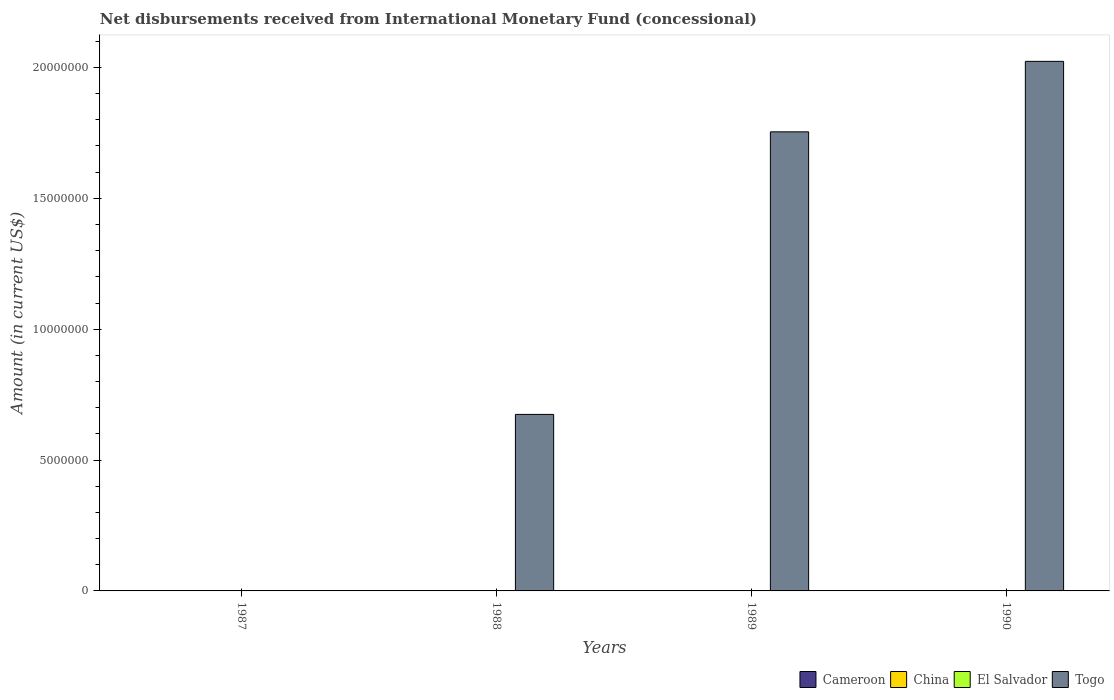How many different coloured bars are there?
Offer a very short reply. 1. Are the number of bars per tick equal to the number of legend labels?
Make the answer very short. No. Are the number of bars on each tick of the X-axis equal?
Provide a succinct answer. No. How many bars are there on the 1st tick from the left?
Your answer should be very brief. 0. How many bars are there on the 3rd tick from the right?
Provide a succinct answer. 1. What is the label of the 2nd group of bars from the left?
Make the answer very short. 1988. What is the amount of disbursements received from International Monetary Fund in China in 1990?
Give a very brief answer. 0. What is the total amount of disbursements received from International Monetary Fund in Togo in the graph?
Your answer should be very brief. 4.45e+07. What is the difference between the amount of disbursements received from International Monetary Fund in Togo in 1988 and that in 1990?
Provide a succinct answer. -1.35e+07. What is the difference between the amount of disbursements received from International Monetary Fund in China in 1989 and the amount of disbursements received from International Monetary Fund in El Salvador in 1990?
Make the answer very short. 0. In how many years, is the amount of disbursements received from International Monetary Fund in El Salvador greater than 10000000 US$?
Give a very brief answer. 0. What is the difference between the highest and the second highest amount of disbursements received from International Monetary Fund in Togo?
Your answer should be compact. 2.69e+06. What is the difference between the highest and the lowest amount of disbursements received from International Monetary Fund in Togo?
Keep it short and to the point. 2.02e+07. In how many years, is the amount of disbursements received from International Monetary Fund in Togo greater than the average amount of disbursements received from International Monetary Fund in Togo taken over all years?
Keep it short and to the point. 2. Is it the case that in every year, the sum of the amount of disbursements received from International Monetary Fund in Togo and amount of disbursements received from International Monetary Fund in El Salvador is greater than the sum of amount of disbursements received from International Monetary Fund in China and amount of disbursements received from International Monetary Fund in Cameroon?
Your answer should be very brief. No. Is it the case that in every year, the sum of the amount of disbursements received from International Monetary Fund in China and amount of disbursements received from International Monetary Fund in Cameroon is greater than the amount of disbursements received from International Monetary Fund in El Salvador?
Offer a very short reply. No. How many bars are there?
Provide a short and direct response. 3. Are all the bars in the graph horizontal?
Give a very brief answer. No. Does the graph contain grids?
Your answer should be very brief. No. How many legend labels are there?
Your answer should be very brief. 4. How are the legend labels stacked?
Your response must be concise. Horizontal. What is the title of the graph?
Provide a succinct answer. Net disbursements received from International Monetary Fund (concessional). Does "Grenada" appear as one of the legend labels in the graph?
Provide a short and direct response. No. What is the label or title of the X-axis?
Provide a succinct answer. Years. What is the Amount (in current US$) in Cameroon in 1987?
Keep it short and to the point. 0. What is the Amount (in current US$) in El Salvador in 1987?
Provide a short and direct response. 0. What is the Amount (in current US$) in China in 1988?
Offer a terse response. 0. What is the Amount (in current US$) of El Salvador in 1988?
Make the answer very short. 0. What is the Amount (in current US$) in Togo in 1988?
Offer a very short reply. 6.74e+06. What is the Amount (in current US$) of China in 1989?
Offer a terse response. 0. What is the Amount (in current US$) of El Salvador in 1989?
Your response must be concise. 0. What is the Amount (in current US$) in Togo in 1989?
Your answer should be compact. 1.75e+07. What is the Amount (in current US$) in Togo in 1990?
Make the answer very short. 2.02e+07. Across all years, what is the maximum Amount (in current US$) in Togo?
Provide a short and direct response. 2.02e+07. Across all years, what is the minimum Amount (in current US$) of Togo?
Your answer should be very brief. 0. What is the total Amount (in current US$) of Cameroon in the graph?
Your answer should be very brief. 0. What is the total Amount (in current US$) in China in the graph?
Give a very brief answer. 0. What is the total Amount (in current US$) in El Salvador in the graph?
Provide a short and direct response. 0. What is the total Amount (in current US$) in Togo in the graph?
Offer a very short reply. 4.45e+07. What is the difference between the Amount (in current US$) of Togo in 1988 and that in 1989?
Your answer should be compact. -1.08e+07. What is the difference between the Amount (in current US$) of Togo in 1988 and that in 1990?
Provide a short and direct response. -1.35e+07. What is the difference between the Amount (in current US$) in Togo in 1989 and that in 1990?
Keep it short and to the point. -2.69e+06. What is the average Amount (in current US$) in China per year?
Provide a succinct answer. 0. What is the average Amount (in current US$) in El Salvador per year?
Give a very brief answer. 0. What is the average Amount (in current US$) of Togo per year?
Make the answer very short. 1.11e+07. What is the ratio of the Amount (in current US$) of Togo in 1988 to that in 1989?
Give a very brief answer. 0.38. What is the ratio of the Amount (in current US$) of Togo in 1988 to that in 1990?
Keep it short and to the point. 0.33. What is the ratio of the Amount (in current US$) in Togo in 1989 to that in 1990?
Keep it short and to the point. 0.87. What is the difference between the highest and the second highest Amount (in current US$) in Togo?
Make the answer very short. 2.69e+06. What is the difference between the highest and the lowest Amount (in current US$) in Togo?
Your answer should be very brief. 2.02e+07. 